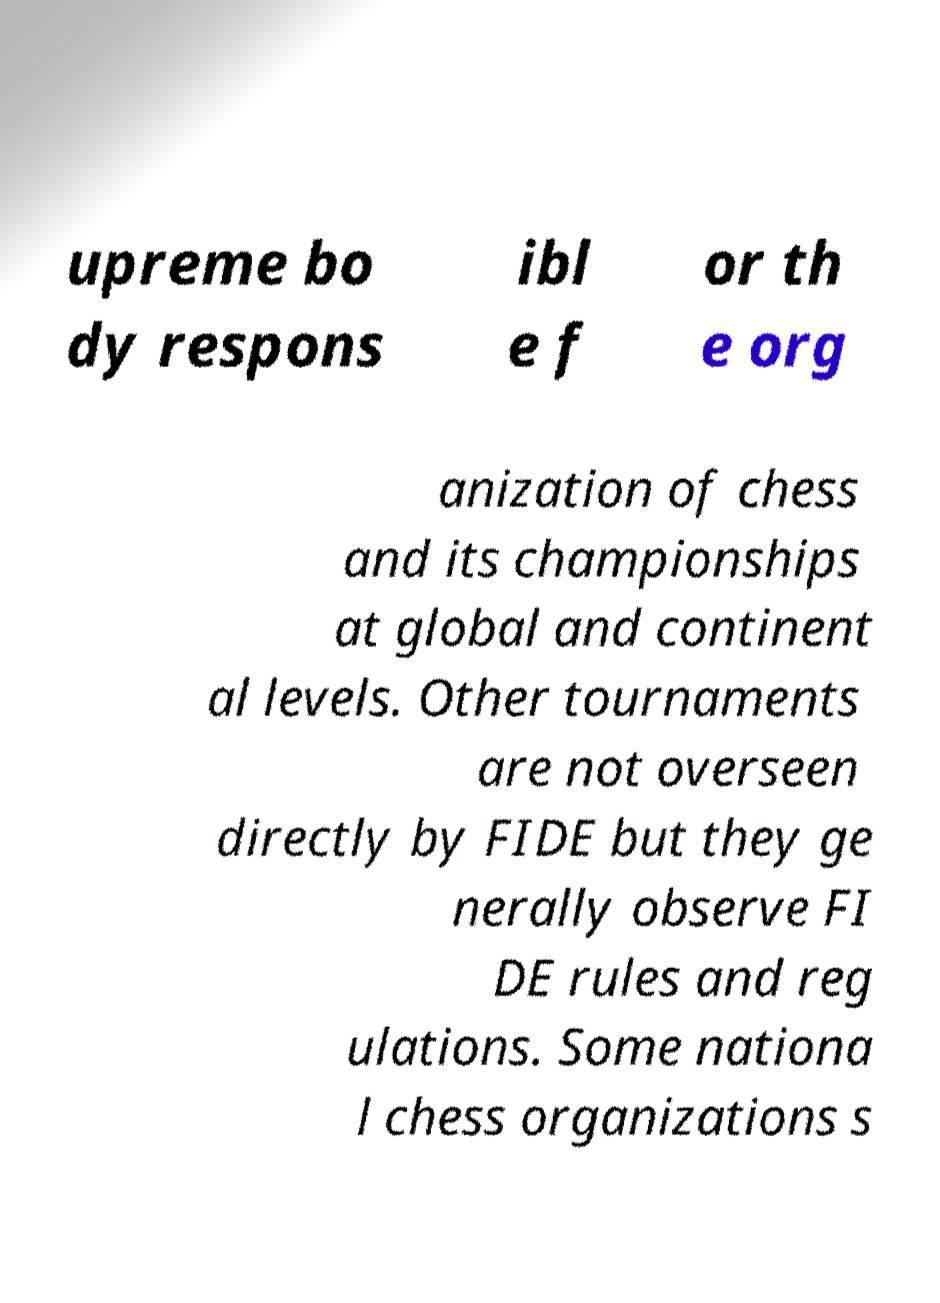Please read and relay the text visible in this image. What does it say? upreme bo dy respons ibl e f or th e org anization of chess and its championships at global and continent al levels. Other tournaments are not overseen directly by FIDE but they ge nerally observe FI DE rules and reg ulations. Some nationa l chess organizations s 